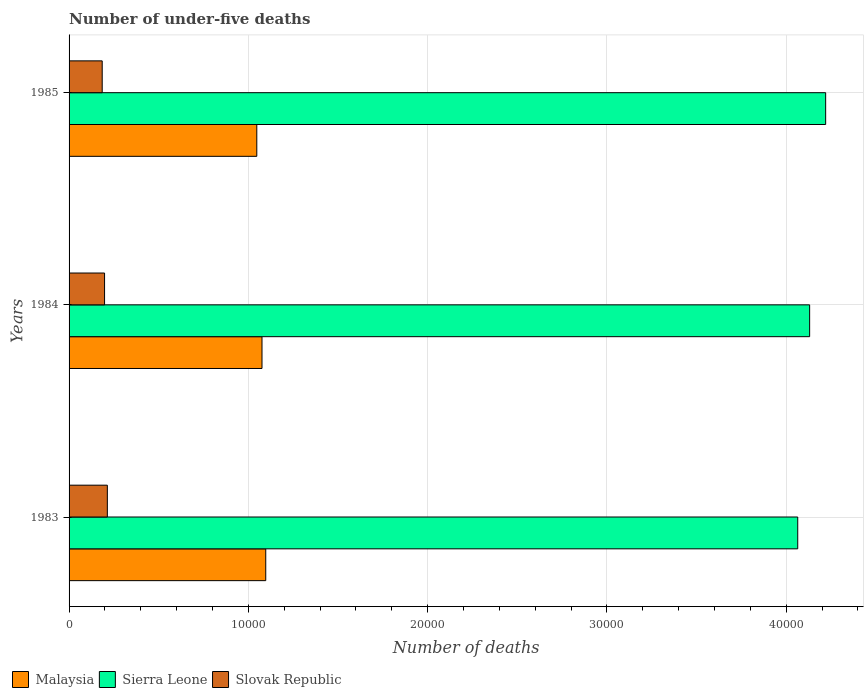How many different coloured bars are there?
Keep it short and to the point. 3. What is the number of under-five deaths in Malaysia in 1984?
Offer a very short reply. 1.08e+04. Across all years, what is the maximum number of under-five deaths in Slovak Republic?
Make the answer very short. 2135. Across all years, what is the minimum number of under-five deaths in Malaysia?
Your response must be concise. 1.05e+04. In which year was the number of under-five deaths in Sierra Leone maximum?
Keep it short and to the point. 1985. What is the total number of under-five deaths in Malaysia in the graph?
Your answer should be very brief. 3.22e+04. What is the difference between the number of under-five deaths in Slovak Republic in 1984 and that in 1985?
Your answer should be very brief. 132. What is the difference between the number of under-five deaths in Sierra Leone in 1985 and the number of under-five deaths in Malaysia in 1984?
Your answer should be compact. 3.14e+04. What is the average number of under-five deaths in Sierra Leone per year?
Make the answer very short. 4.14e+04. In the year 1985, what is the difference between the number of under-five deaths in Slovak Republic and number of under-five deaths in Sierra Leone?
Keep it short and to the point. -4.04e+04. In how many years, is the number of under-five deaths in Malaysia greater than 30000 ?
Your answer should be compact. 0. What is the ratio of the number of under-five deaths in Sierra Leone in 1984 to that in 1985?
Give a very brief answer. 0.98. Is the difference between the number of under-five deaths in Slovak Republic in 1984 and 1985 greater than the difference between the number of under-five deaths in Sierra Leone in 1984 and 1985?
Offer a very short reply. Yes. What is the difference between the highest and the second highest number of under-five deaths in Sierra Leone?
Offer a terse response. 894. What is the difference between the highest and the lowest number of under-five deaths in Slovak Republic?
Provide a succinct answer. 287. In how many years, is the number of under-five deaths in Slovak Republic greater than the average number of under-five deaths in Slovak Republic taken over all years?
Offer a terse response. 1. What does the 3rd bar from the top in 1985 represents?
Offer a terse response. Malaysia. What does the 2nd bar from the bottom in 1983 represents?
Give a very brief answer. Sierra Leone. Is it the case that in every year, the sum of the number of under-five deaths in Slovak Republic and number of under-five deaths in Malaysia is greater than the number of under-five deaths in Sierra Leone?
Provide a succinct answer. No. How many bars are there?
Keep it short and to the point. 9. How many years are there in the graph?
Your answer should be very brief. 3. What is the difference between two consecutive major ticks on the X-axis?
Provide a succinct answer. 10000. Are the values on the major ticks of X-axis written in scientific E-notation?
Provide a short and direct response. No. Does the graph contain grids?
Make the answer very short. Yes. Where does the legend appear in the graph?
Ensure brevity in your answer.  Bottom left. How are the legend labels stacked?
Offer a very short reply. Horizontal. What is the title of the graph?
Offer a very short reply. Number of under-five deaths. What is the label or title of the X-axis?
Your answer should be very brief. Number of deaths. What is the label or title of the Y-axis?
Your answer should be very brief. Years. What is the Number of deaths in Malaysia in 1983?
Keep it short and to the point. 1.10e+04. What is the Number of deaths of Sierra Leone in 1983?
Keep it short and to the point. 4.06e+04. What is the Number of deaths in Slovak Republic in 1983?
Keep it short and to the point. 2135. What is the Number of deaths of Malaysia in 1984?
Your answer should be compact. 1.08e+04. What is the Number of deaths of Sierra Leone in 1984?
Provide a succinct answer. 4.13e+04. What is the Number of deaths of Slovak Republic in 1984?
Offer a very short reply. 1980. What is the Number of deaths of Malaysia in 1985?
Offer a terse response. 1.05e+04. What is the Number of deaths in Sierra Leone in 1985?
Give a very brief answer. 4.22e+04. What is the Number of deaths of Slovak Republic in 1985?
Your answer should be very brief. 1848. Across all years, what is the maximum Number of deaths in Malaysia?
Provide a succinct answer. 1.10e+04. Across all years, what is the maximum Number of deaths in Sierra Leone?
Offer a terse response. 4.22e+04. Across all years, what is the maximum Number of deaths of Slovak Republic?
Your answer should be very brief. 2135. Across all years, what is the minimum Number of deaths in Malaysia?
Provide a succinct answer. 1.05e+04. Across all years, what is the minimum Number of deaths in Sierra Leone?
Give a very brief answer. 4.06e+04. Across all years, what is the minimum Number of deaths of Slovak Republic?
Provide a short and direct response. 1848. What is the total Number of deaths in Malaysia in the graph?
Your answer should be very brief. 3.22e+04. What is the total Number of deaths of Sierra Leone in the graph?
Give a very brief answer. 1.24e+05. What is the total Number of deaths in Slovak Republic in the graph?
Your answer should be very brief. 5963. What is the difference between the Number of deaths in Malaysia in 1983 and that in 1984?
Ensure brevity in your answer.  209. What is the difference between the Number of deaths in Sierra Leone in 1983 and that in 1984?
Your answer should be very brief. -664. What is the difference between the Number of deaths in Slovak Republic in 1983 and that in 1984?
Offer a very short reply. 155. What is the difference between the Number of deaths of Malaysia in 1983 and that in 1985?
Offer a terse response. 499. What is the difference between the Number of deaths of Sierra Leone in 1983 and that in 1985?
Your answer should be compact. -1558. What is the difference between the Number of deaths of Slovak Republic in 1983 and that in 1985?
Make the answer very short. 287. What is the difference between the Number of deaths of Malaysia in 1984 and that in 1985?
Give a very brief answer. 290. What is the difference between the Number of deaths in Sierra Leone in 1984 and that in 1985?
Give a very brief answer. -894. What is the difference between the Number of deaths of Slovak Republic in 1984 and that in 1985?
Provide a short and direct response. 132. What is the difference between the Number of deaths in Malaysia in 1983 and the Number of deaths in Sierra Leone in 1984?
Provide a short and direct response. -3.03e+04. What is the difference between the Number of deaths of Malaysia in 1983 and the Number of deaths of Slovak Republic in 1984?
Offer a very short reply. 8990. What is the difference between the Number of deaths of Sierra Leone in 1983 and the Number of deaths of Slovak Republic in 1984?
Ensure brevity in your answer.  3.87e+04. What is the difference between the Number of deaths in Malaysia in 1983 and the Number of deaths in Sierra Leone in 1985?
Provide a short and direct response. -3.12e+04. What is the difference between the Number of deaths in Malaysia in 1983 and the Number of deaths in Slovak Republic in 1985?
Your answer should be compact. 9122. What is the difference between the Number of deaths of Sierra Leone in 1983 and the Number of deaths of Slovak Republic in 1985?
Your response must be concise. 3.88e+04. What is the difference between the Number of deaths of Malaysia in 1984 and the Number of deaths of Sierra Leone in 1985?
Your response must be concise. -3.14e+04. What is the difference between the Number of deaths of Malaysia in 1984 and the Number of deaths of Slovak Republic in 1985?
Your response must be concise. 8913. What is the difference between the Number of deaths of Sierra Leone in 1984 and the Number of deaths of Slovak Republic in 1985?
Make the answer very short. 3.95e+04. What is the average Number of deaths of Malaysia per year?
Your response must be concise. 1.07e+04. What is the average Number of deaths of Sierra Leone per year?
Offer a terse response. 4.14e+04. What is the average Number of deaths of Slovak Republic per year?
Ensure brevity in your answer.  1987.67. In the year 1983, what is the difference between the Number of deaths of Malaysia and Number of deaths of Sierra Leone?
Offer a very short reply. -2.97e+04. In the year 1983, what is the difference between the Number of deaths in Malaysia and Number of deaths in Slovak Republic?
Offer a terse response. 8835. In the year 1983, what is the difference between the Number of deaths in Sierra Leone and Number of deaths in Slovak Republic?
Give a very brief answer. 3.85e+04. In the year 1984, what is the difference between the Number of deaths of Malaysia and Number of deaths of Sierra Leone?
Ensure brevity in your answer.  -3.05e+04. In the year 1984, what is the difference between the Number of deaths in Malaysia and Number of deaths in Slovak Republic?
Keep it short and to the point. 8781. In the year 1984, what is the difference between the Number of deaths of Sierra Leone and Number of deaths of Slovak Republic?
Provide a succinct answer. 3.93e+04. In the year 1985, what is the difference between the Number of deaths of Malaysia and Number of deaths of Sierra Leone?
Your response must be concise. -3.17e+04. In the year 1985, what is the difference between the Number of deaths in Malaysia and Number of deaths in Slovak Republic?
Provide a short and direct response. 8623. In the year 1985, what is the difference between the Number of deaths of Sierra Leone and Number of deaths of Slovak Republic?
Give a very brief answer. 4.04e+04. What is the ratio of the Number of deaths of Malaysia in 1983 to that in 1984?
Offer a very short reply. 1.02. What is the ratio of the Number of deaths in Sierra Leone in 1983 to that in 1984?
Provide a short and direct response. 0.98. What is the ratio of the Number of deaths of Slovak Republic in 1983 to that in 1984?
Your answer should be compact. 1.08. What is the ratio of the Number of deaths in Malaysia in 1983 to that in 1985?
Your answer should be very brief. 1.05. What is the ratio of the Number of deaths of Sierra Leone in 1983 to that in 1985?
Make the answer very short. 0.96. What is the ratio of the Number of deaths of Slovak Republic in 1983 to that in 1985?
Keep it short and to the point. 1.16. What is the ratio of the Number of deaths in Malaysia in 1984 to that in 1985?
Your answer should be compact. 1.03. What is the ratio of the Number of deaths in Sierra Leone in 1984 to that in 1985?
Your answer should be compact. 0.98. What is the ratio of the Number of deaths of Slovak Republic in 1984 to that in 1985?
Your answer should be compact. 1.07. What is the difference between the highest and the second highest Number of deaths of Malaysia?
Keep it short and to the point. 209. What is the difference between the highest and the second highest Number of deaths in Sierra Leone?
Offer a very short reply. 894. What is the difference between the highest and the second highest Number of deaths in Slovak Republic?
Your answer should be compact. 155. What is the difference between the highest and the lowest Number of deaths of Malaysia?
Provide a succinct answer. 499. What is the difference between the highest and the lowest Number of deaths in Sierra Leone?
Give a very brief answer. 1558. What is the difference between the highest and the lowest Number of deaths of Slovak Republic?
Your answer should be compact. 287. 